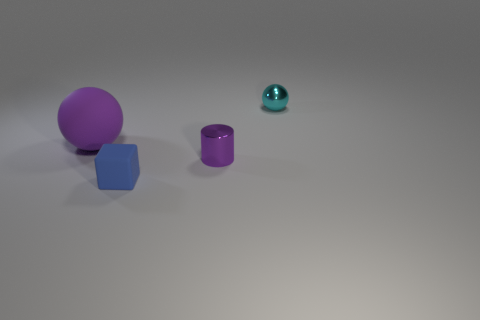Is the material of the small cyan sphere the same as the sphere that is left of the tiny sphere?
Keep it short and to the point. No. How many other objects are there of the same material as the tiny purple cylinder?
Your answer should be very brief. 1. There is a tiny metal object that is in front of the metallic object behind the large purple matte thing; how many tiny metallic balls are behind it?
Your response must be concise. 1. There is a purple object that is to the left of the matte cube; is its size the same as the tiny purple cylinder?
Offer a very short reply. No. Are there fewer blue rubber cubes that are behind the blue thing than small spheres on the left side of the big purple ball?
Keep it short and to the point. No. Is the color of the large object the same as the block?
Offer a terse response. No. Are there fewer large matte things to the left of the big purple object than tiny blue blocks?
Give a very brief answer. Yes. There is a object that is the same color as the big rubber sphere; what material is it?
Ensure brevity in your answer.  Metal. Does the small cyan ball have the same material as the blue cube?
Your answer should be compact. No. How many blue blocks are the same material as the big purple ball?
Ensure brevity in your answer.  1. 